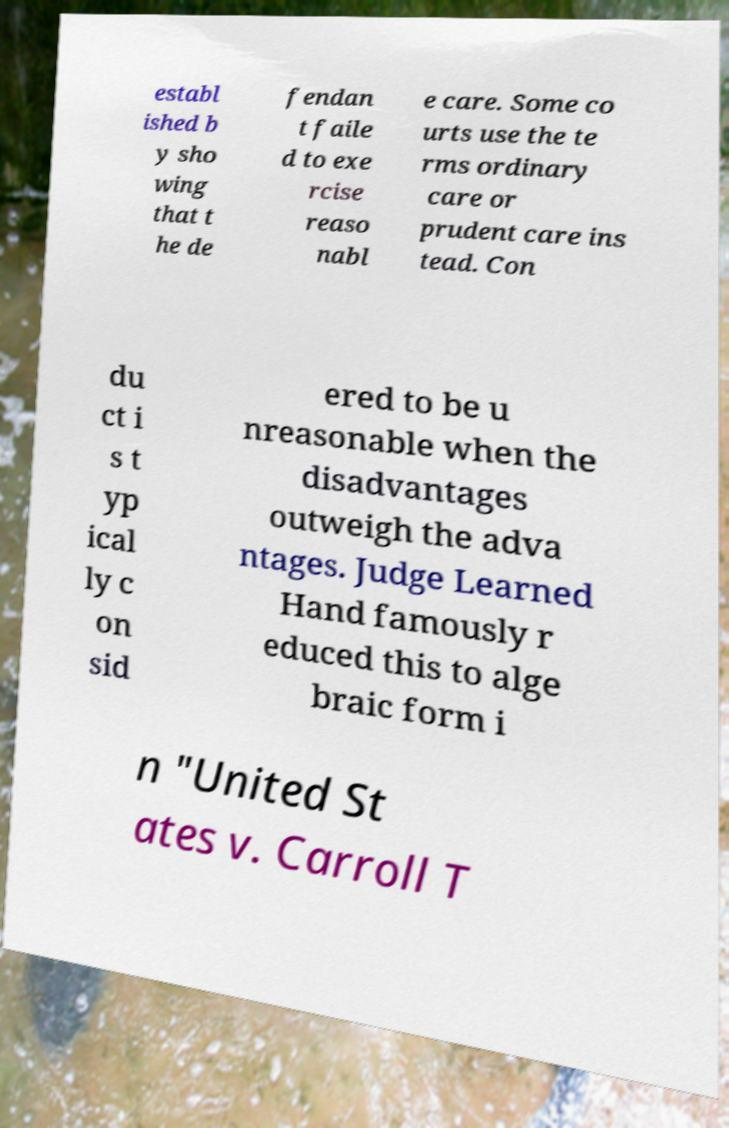Please identify and transcribe the text found in this image. establ ished b y sho wing that t he de fendan t faile d to exe rcise reaso nabl e care. Some co urts use the te rms ordinary care or prudent care ins tead. Con du ct i s t yp ical ly c on sid ered to be u nreasonable when the disadvantages outweigh the adva ntages. Judge Learned Hand famously r educed this to alge braic form i n "United St ates v. Carroll T 